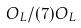<formula> <loc_0><loc_0><loc_500><loc_500>O _ { L } / ( 7 ) O _ { L }</formula> 